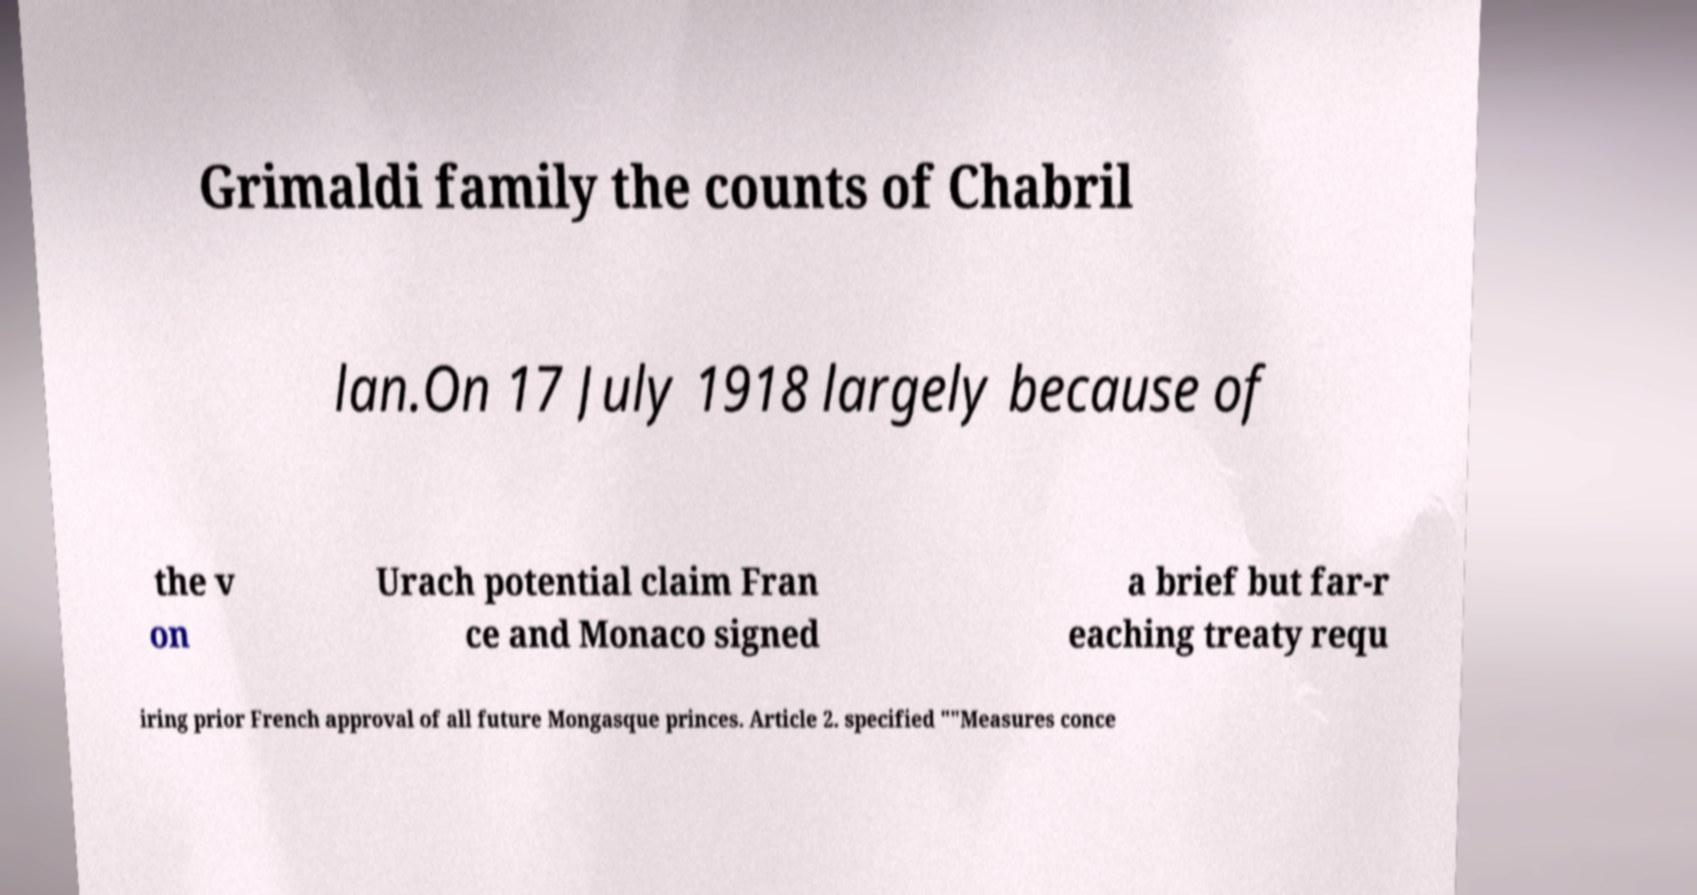For documentation purposes, I need the text within this image transcribed. Could you provide that? Grimaldi family the counts of Chabril lan.On 17 July 1918 largely because of the v on Urach potential claim Fran ce and Monaco signed a brief but far-r eaching treaty requ iring prior French approval of all future Mongasque princes. Article 2. specified ""Measures conce 